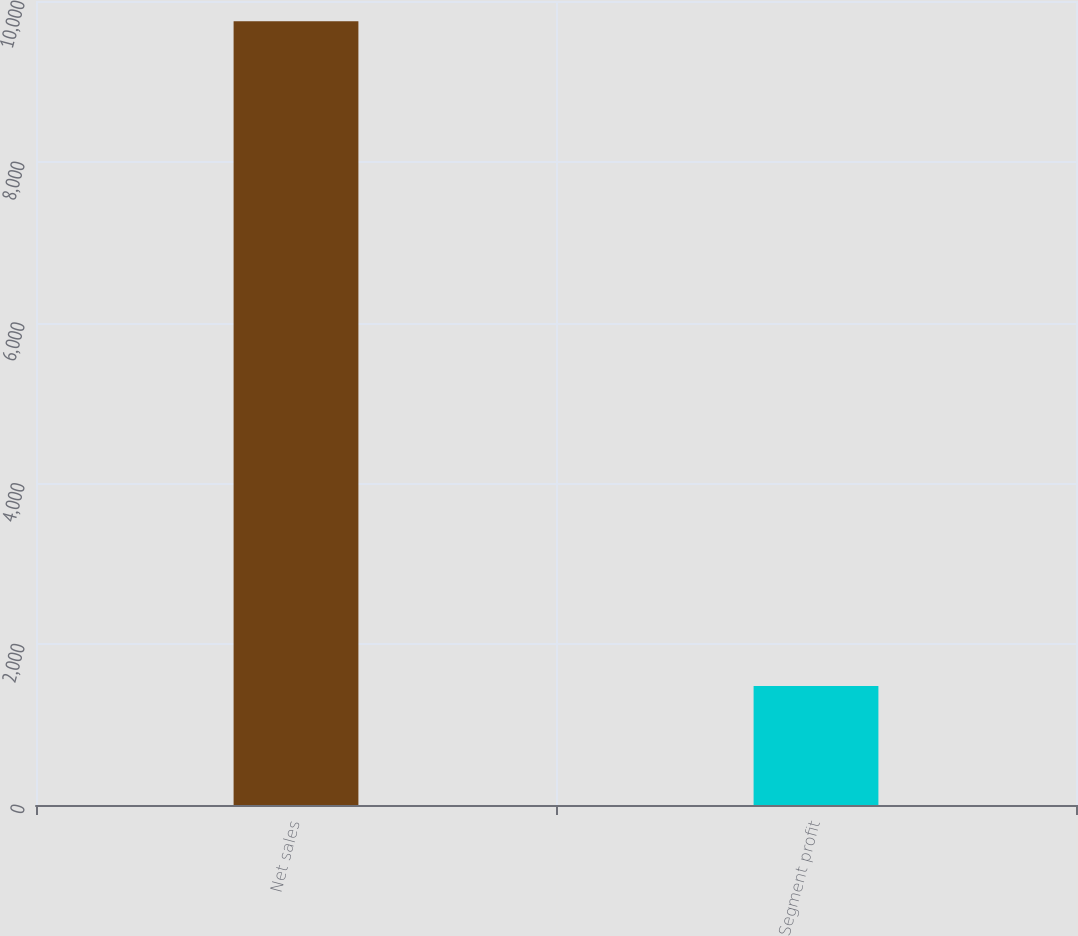<chart> <loc_0><loc_0><loc_500><loc_500><bar_chart><fcel>Net sales<fcel>Segment profit<nl><fcel>9748<fcel>1479<nl></chart> 